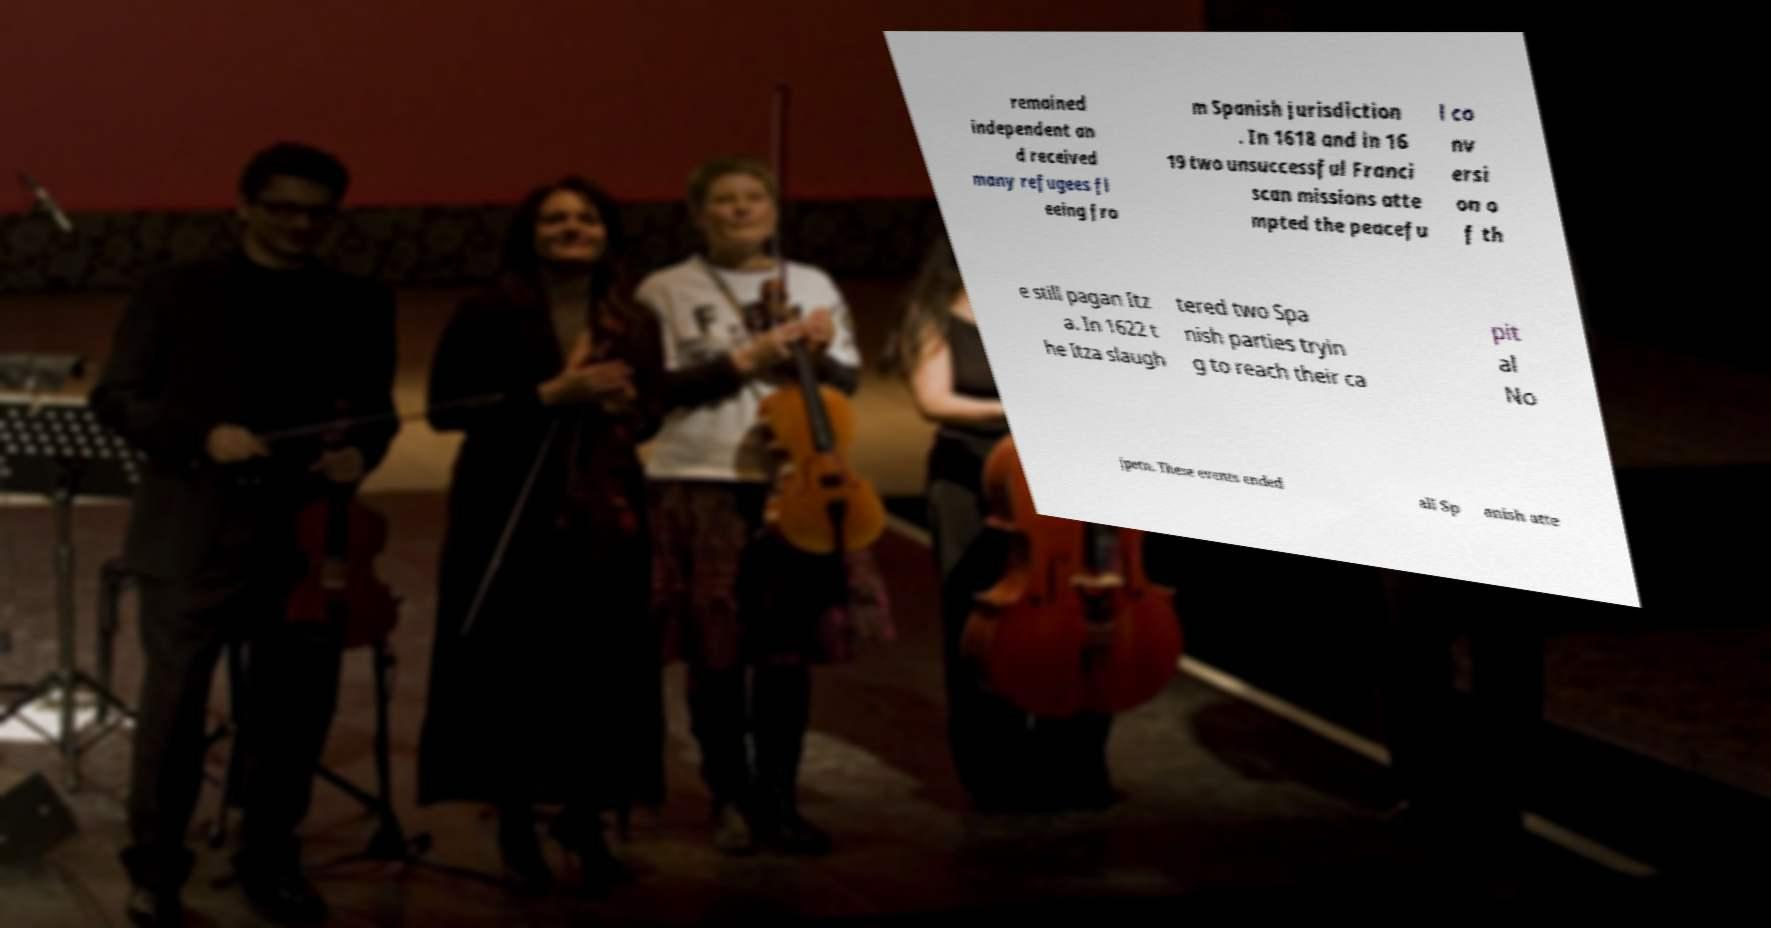Please identify and transcribe the text found in this image. remained independent an d received many refugees fl eeing fro m Spanish jurisdiction . In 1618 and in 16 19 two unsuccessful Franci scan missions atte mpted the peacefu l co nv ersi on o f th e still pagan Itz a. In 1622 t he Itza slaugh tered two Spa nish parties tryin g to reach their ca pit al No jpetn. These events ended all Sp anish atte 